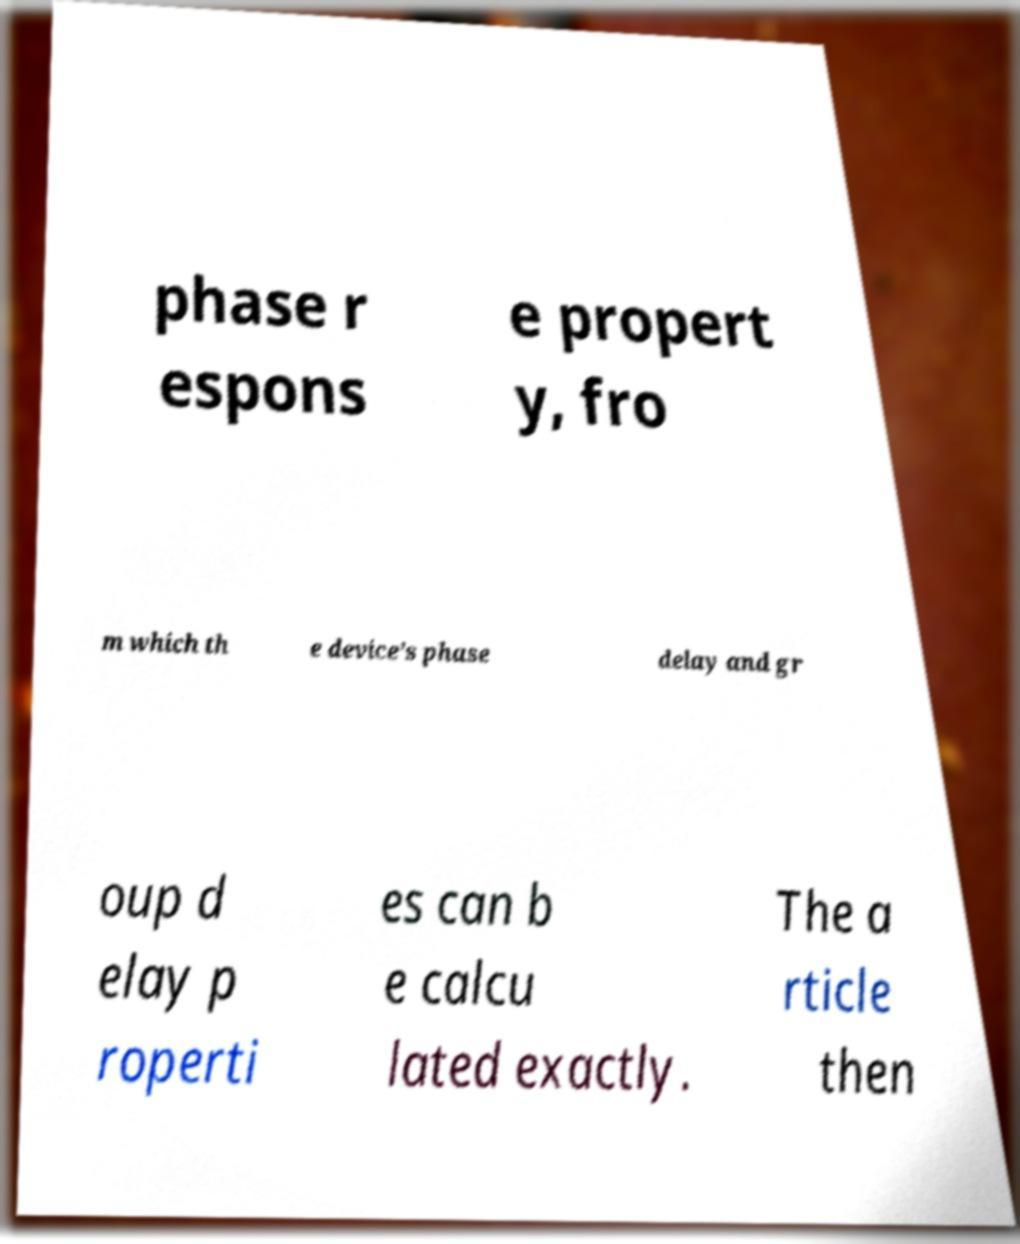Please read and relay the text visible in this image. What does it say? phase r espons e propert y, fro m which th e device’s phase delay and gr oup d elay p roperti es can b e calcu lated exactly. The a rticle then 